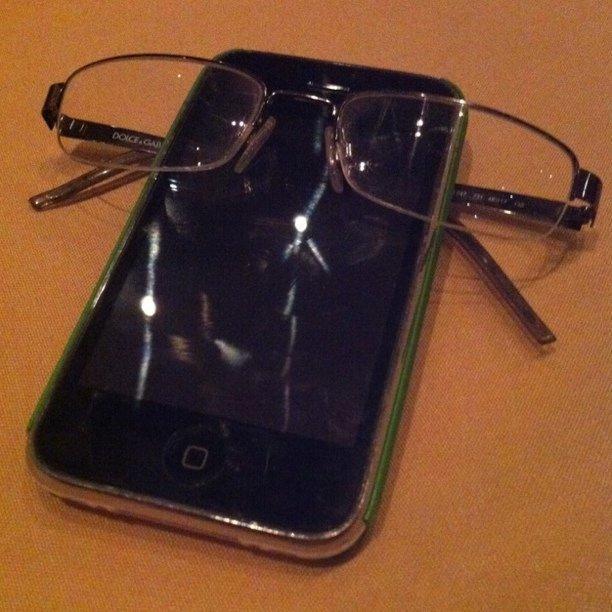How many chocolate donuts are there?
Give a very brief answer. 0. 